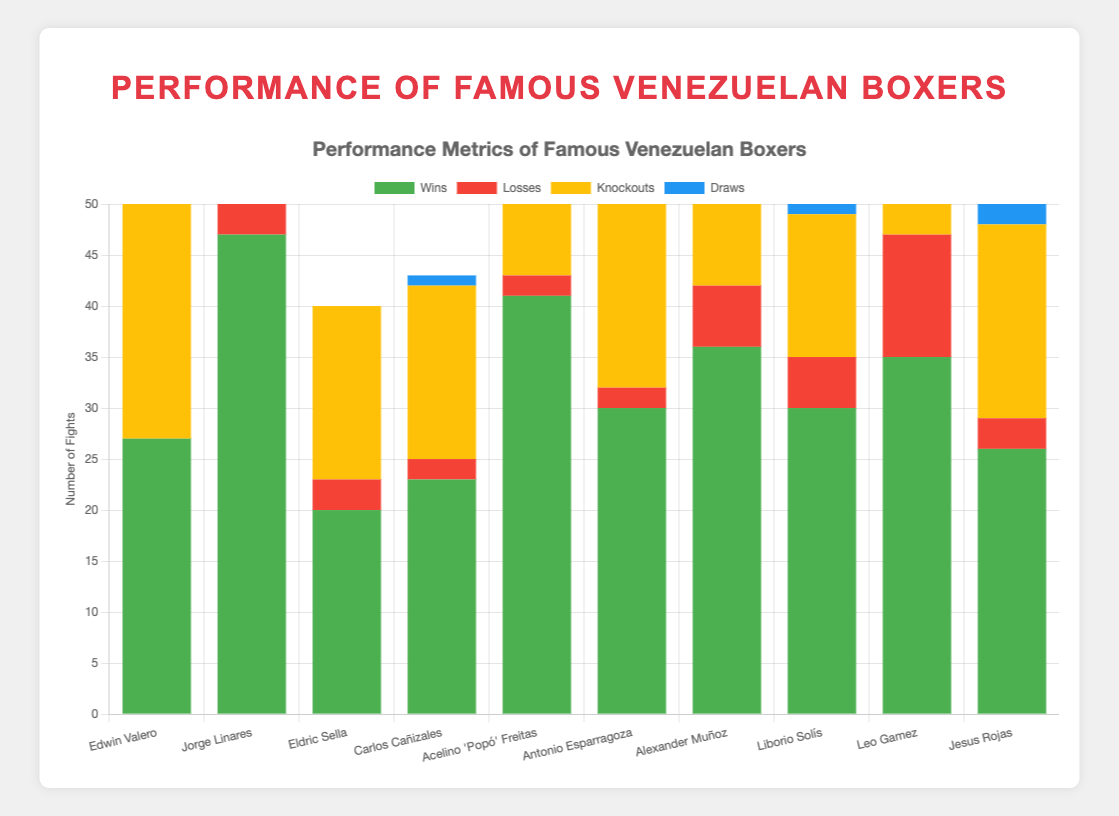What's the total number of wins for boxers in the Lightweight weight class? Edwin Valero has 27 wins and Jorge Linares has 47 wins. The total number of wins is 27 + 47.
Answer: 74 Which boxer has the highest number of knockouts and how many do they have? The boxer with the highest number of knockouts is Acelino 'Popó' Freitas with 34 knockouts.
Answer: Acelino 'Popó' Freitas with 34 knockouts How many more wins does Jorge Linares have compared to Edwin Valero? Jorge Linares has 47 wins, and Edwin Valero has 27 wins. The difference is 47 - 27.
Answer: 20 Which boxer in the Bantamweight class has more wins, and how many more? Alexander Muñoz has 36 wins, and Liborio Solís has 30 wins. Alexander Muñoz has 36 - 30 more wins than Liborio Solís.
Answer: Alexander Muñoz, 6 Who has more losses, Leo Gamez or Eldric Sella, and by how many? Leo Gamez has 12 losses, and Eldric Sella has 3 losses. Leo Gamez has 12 - 3 more losses than Eldric Sella.
Answer: Leo Gamez, 9 What is the average number of knockouts of all the boxers? The total number of knockouts is 27 + 29 + 17 + 17 + 34 + 26 + 28 + 14 + 26 + 19 = 237. There are 10 boxers: 237/10 = 23.7.
Answer: 23.7 Which boxer has the highest number of draws and how many? Antonio Esparragoza has the highest number of draws, which is 4.
Answer: Antonio Esparragoza with 4 draws Which weight class has the combined most wins, and what is the total number of wins? Lightweight has the most combined wins. Edwin Valero has 27 wins and Jorge Linares has 47 wins, which totals 74 wins.
Answer: Lightweight with 74 wins What's the ratio of wins to losses for Jorge Linares? Jorge Linares has 47 wins and 5 losses. The ratio of wins to losses is 47/5.
Answer: 9.4:1 Who has a higher ratio of knockouts to total wins, Edwin Valero or Eldric Sella and by what ratio difference? Edwin Valero has 27 knockouts out of 27 wins (ratio = 1). Eldric Sella has 17 knockouts out of 20 wins (ratio = 0.85). The difference between the ratios is 1 - 0.85.
Answer: Edwin Valero by 0.15 